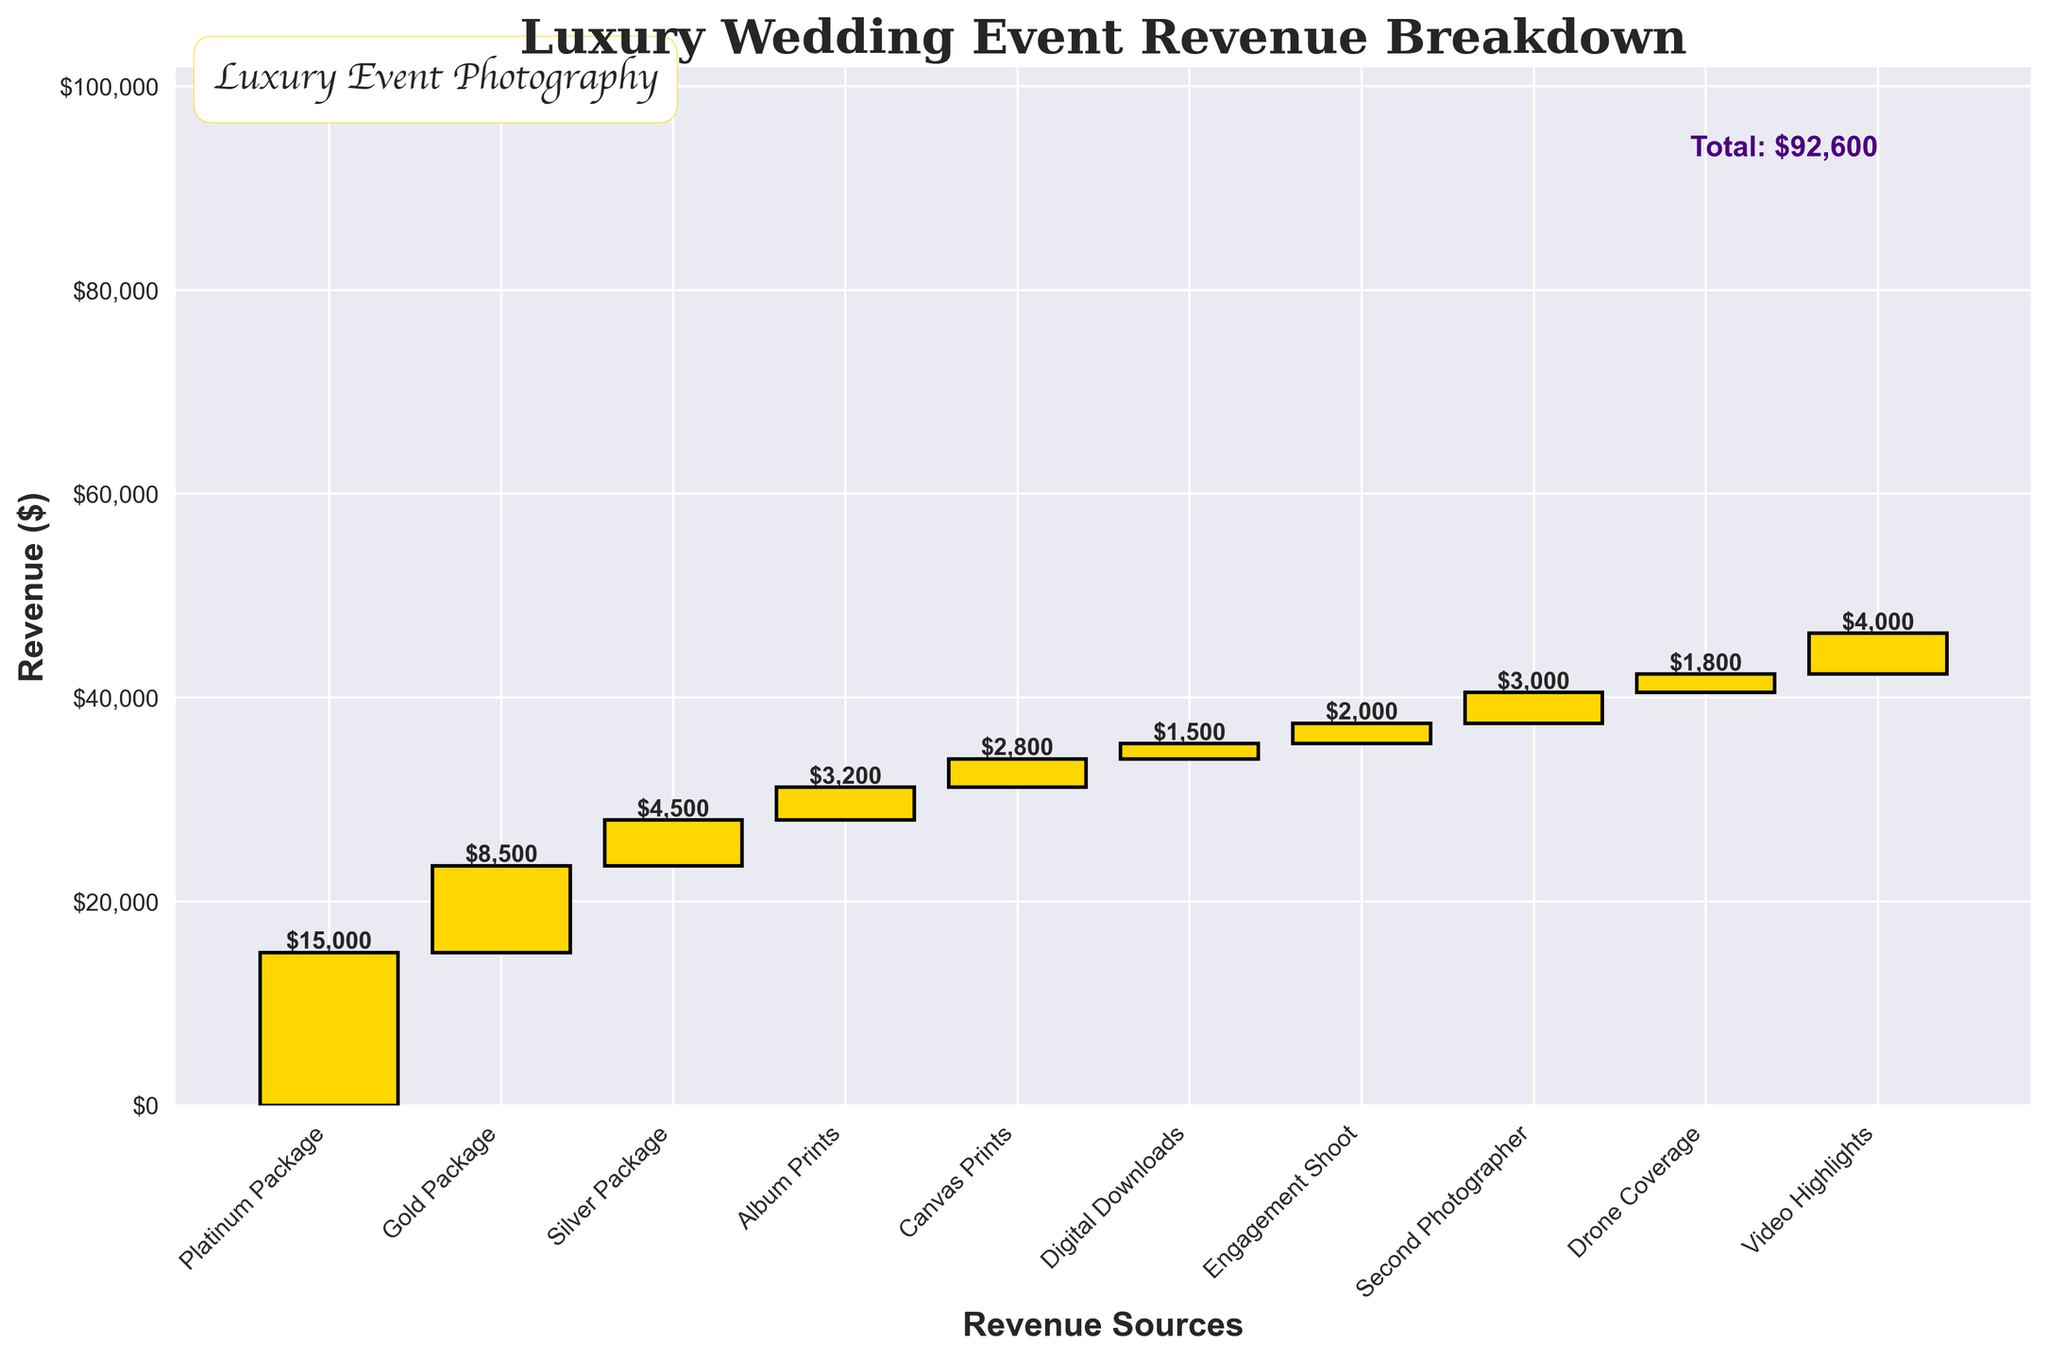What is the title of the waterfall chart? The title of the chart is located at the top of the figure, clearly stating the main topic of the chart.
Answer: Luxury Wedding Event Revenue Breakdown How much revenue is generated from the Platinum Package? Locate the Platinum Package bar on the x-axis and read its corresponding value label on the y-axis. The value is directly labeled on the bar.
Answer: $15,000 Which category generates the least revenue and how much is it? Compare the heights of all the bars to find the shortest one and note its label value. The shortest bar corresponds to Digital Downloads.
Answer: Digital Downloads, $1,500 How much total revenue is generated from all photography packages (Platinum, Gold, Silver)? Sum the revenue from the Platinum Package, Gold Package, and Silver Package by adding their values: 15,000 + 8,500 + 4,500.
Answer: $28,000 What is the second highest revenue-generating category and its value? Identify the bars, locate the highest bar, skip it, and find the second tallest bar and its label. The second highest bar represents the Gold Package.
Answer: Gold Package, $8,500 Compare the revenue from Canvas Prints and Album Prints. Which one is higher and by how much? Locate both Canvas Prints and Album Prints bars, read their values, and find the difference: 3,200 - 2,800.
Answer: Album Prints is higher by $400 What percentage of the total revenue is generated by the Platinum Package? Calculate the percentage by taking the revenue from the Platinum Package and dividing by the total revenue, then multiply by 100: (15,000 / 46,300) * 100.
Answer: Approximately 32.4% What is the combined revenue from the engagement shoot and the drone coverage? Sum the values of the Engagement Shoot and Drone Coverage: 2,000 + 1,800.
Answer: $3,800 How much more revenue is generated by Video Highlights compared to Digital Downloads? Find the difference between Video Highlights and Digital Downloads values: 4,000 - 1,500.
Answer: $2,500 What is the revenue difference between the Silver Package and the Second Photographer? Subtract the revenue value of the Second Photographer from the Silver Package: 4,500 - 3,000.
Answer: $1,500 